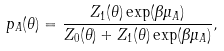Convert formula to latex. <formula><loc_0><loc_0><loc_500><loc_500>p _ { A } ( \theta ) = \frac { Z _ { 1 } ( \theta ) \exp ( \beta \mu _ { A } ) } { Z _ { 0 } ( \theta ) + Z _ { 1 } ( \theta ) \exp ( \beta \mu _ { A } ) } ,</formula> 